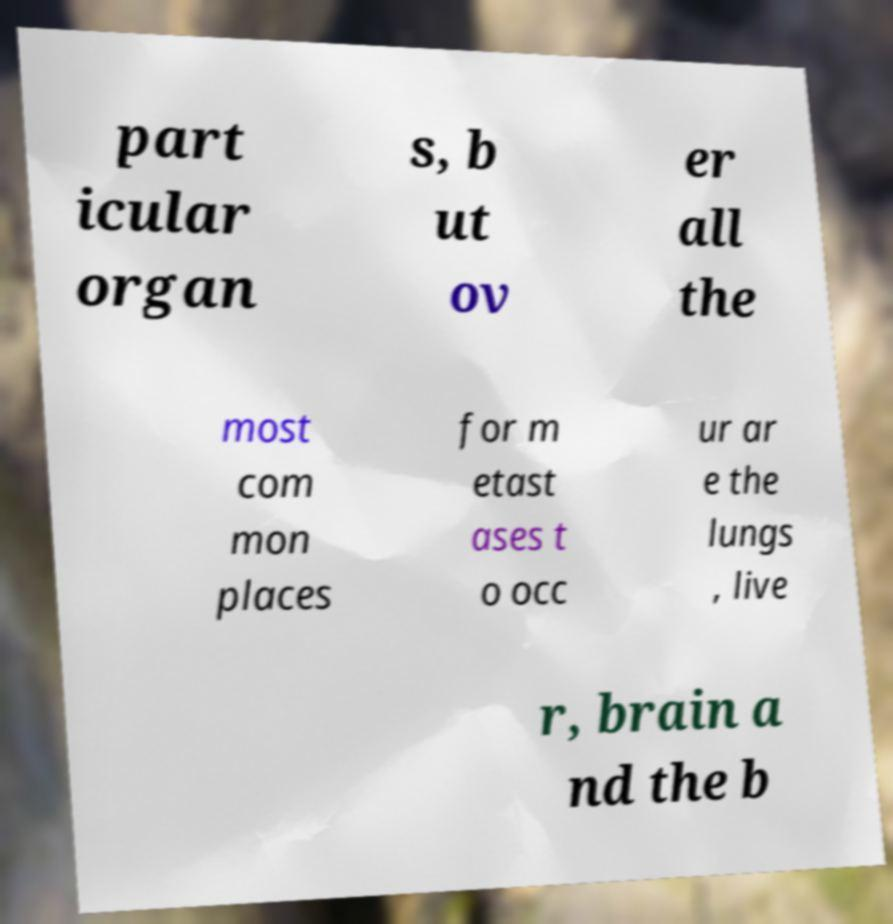I need the written content from this picture converted into text. Can you do that? part icular organ s, b ut ov er all the most com mon places for m etast ases t o occ ur ar e the lungs , live r, brain a nd the b 